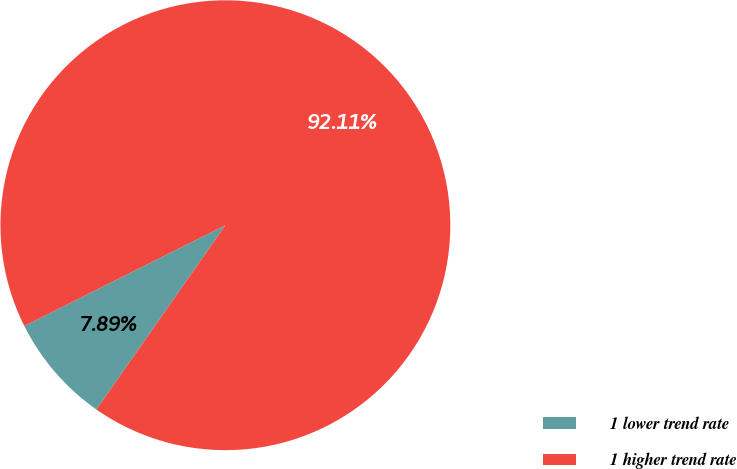Convert chart to OTSL. <chart><loc_0><loc_0><loc_500><loc_500><pie_chart><fcel>1 lower trend rate<fcel>1 higher trend rate<nl><fcel>7.89%<fcel>92.11%<nl></chart> 